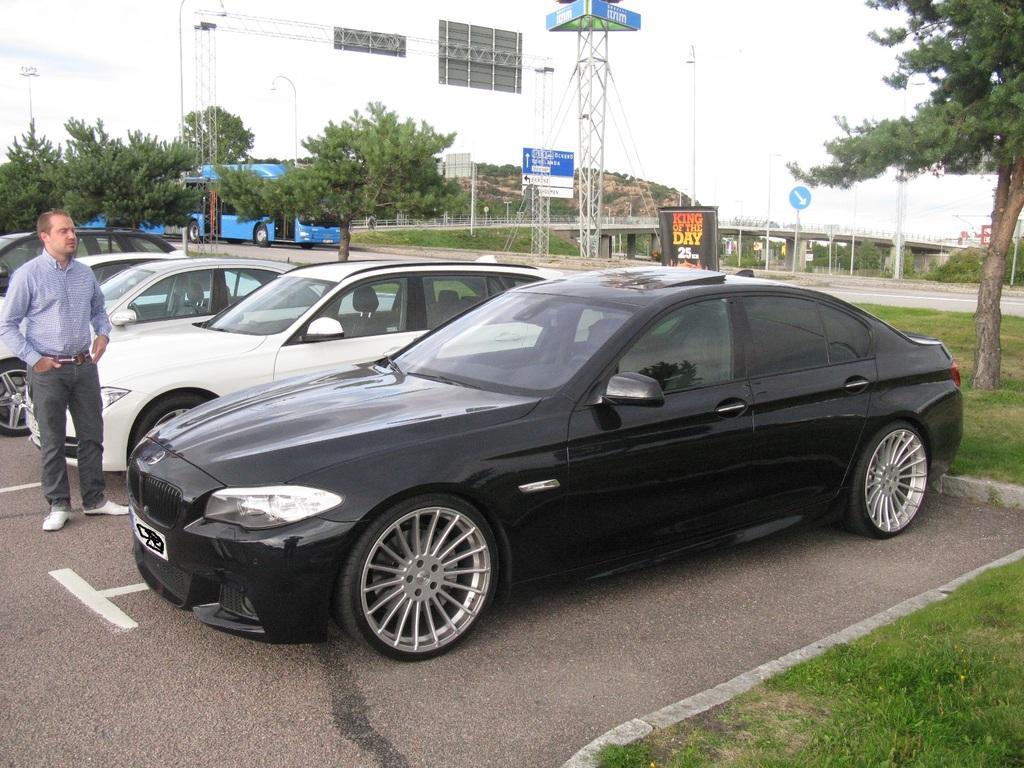Could you give a brief overview of what you see in this image? In this image we can see these cars parked here and we can see a person standing here. Here we can see grass, trees, boards, poles, banners, a blue color vehicle, bridge, hills and sky in the background. 